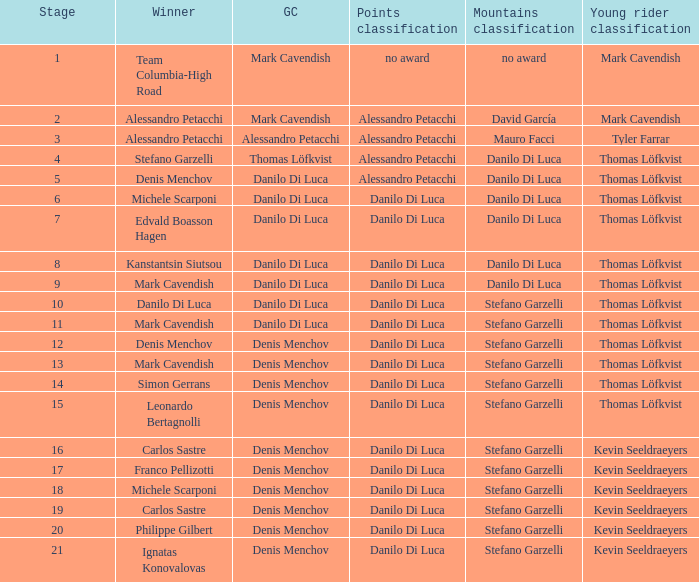When thomas löfkvist is the  young rider classification and alessandro petacchi is the points classification who are the general classifications?  Thomas Löfkvist, Danilo Di Luca. 